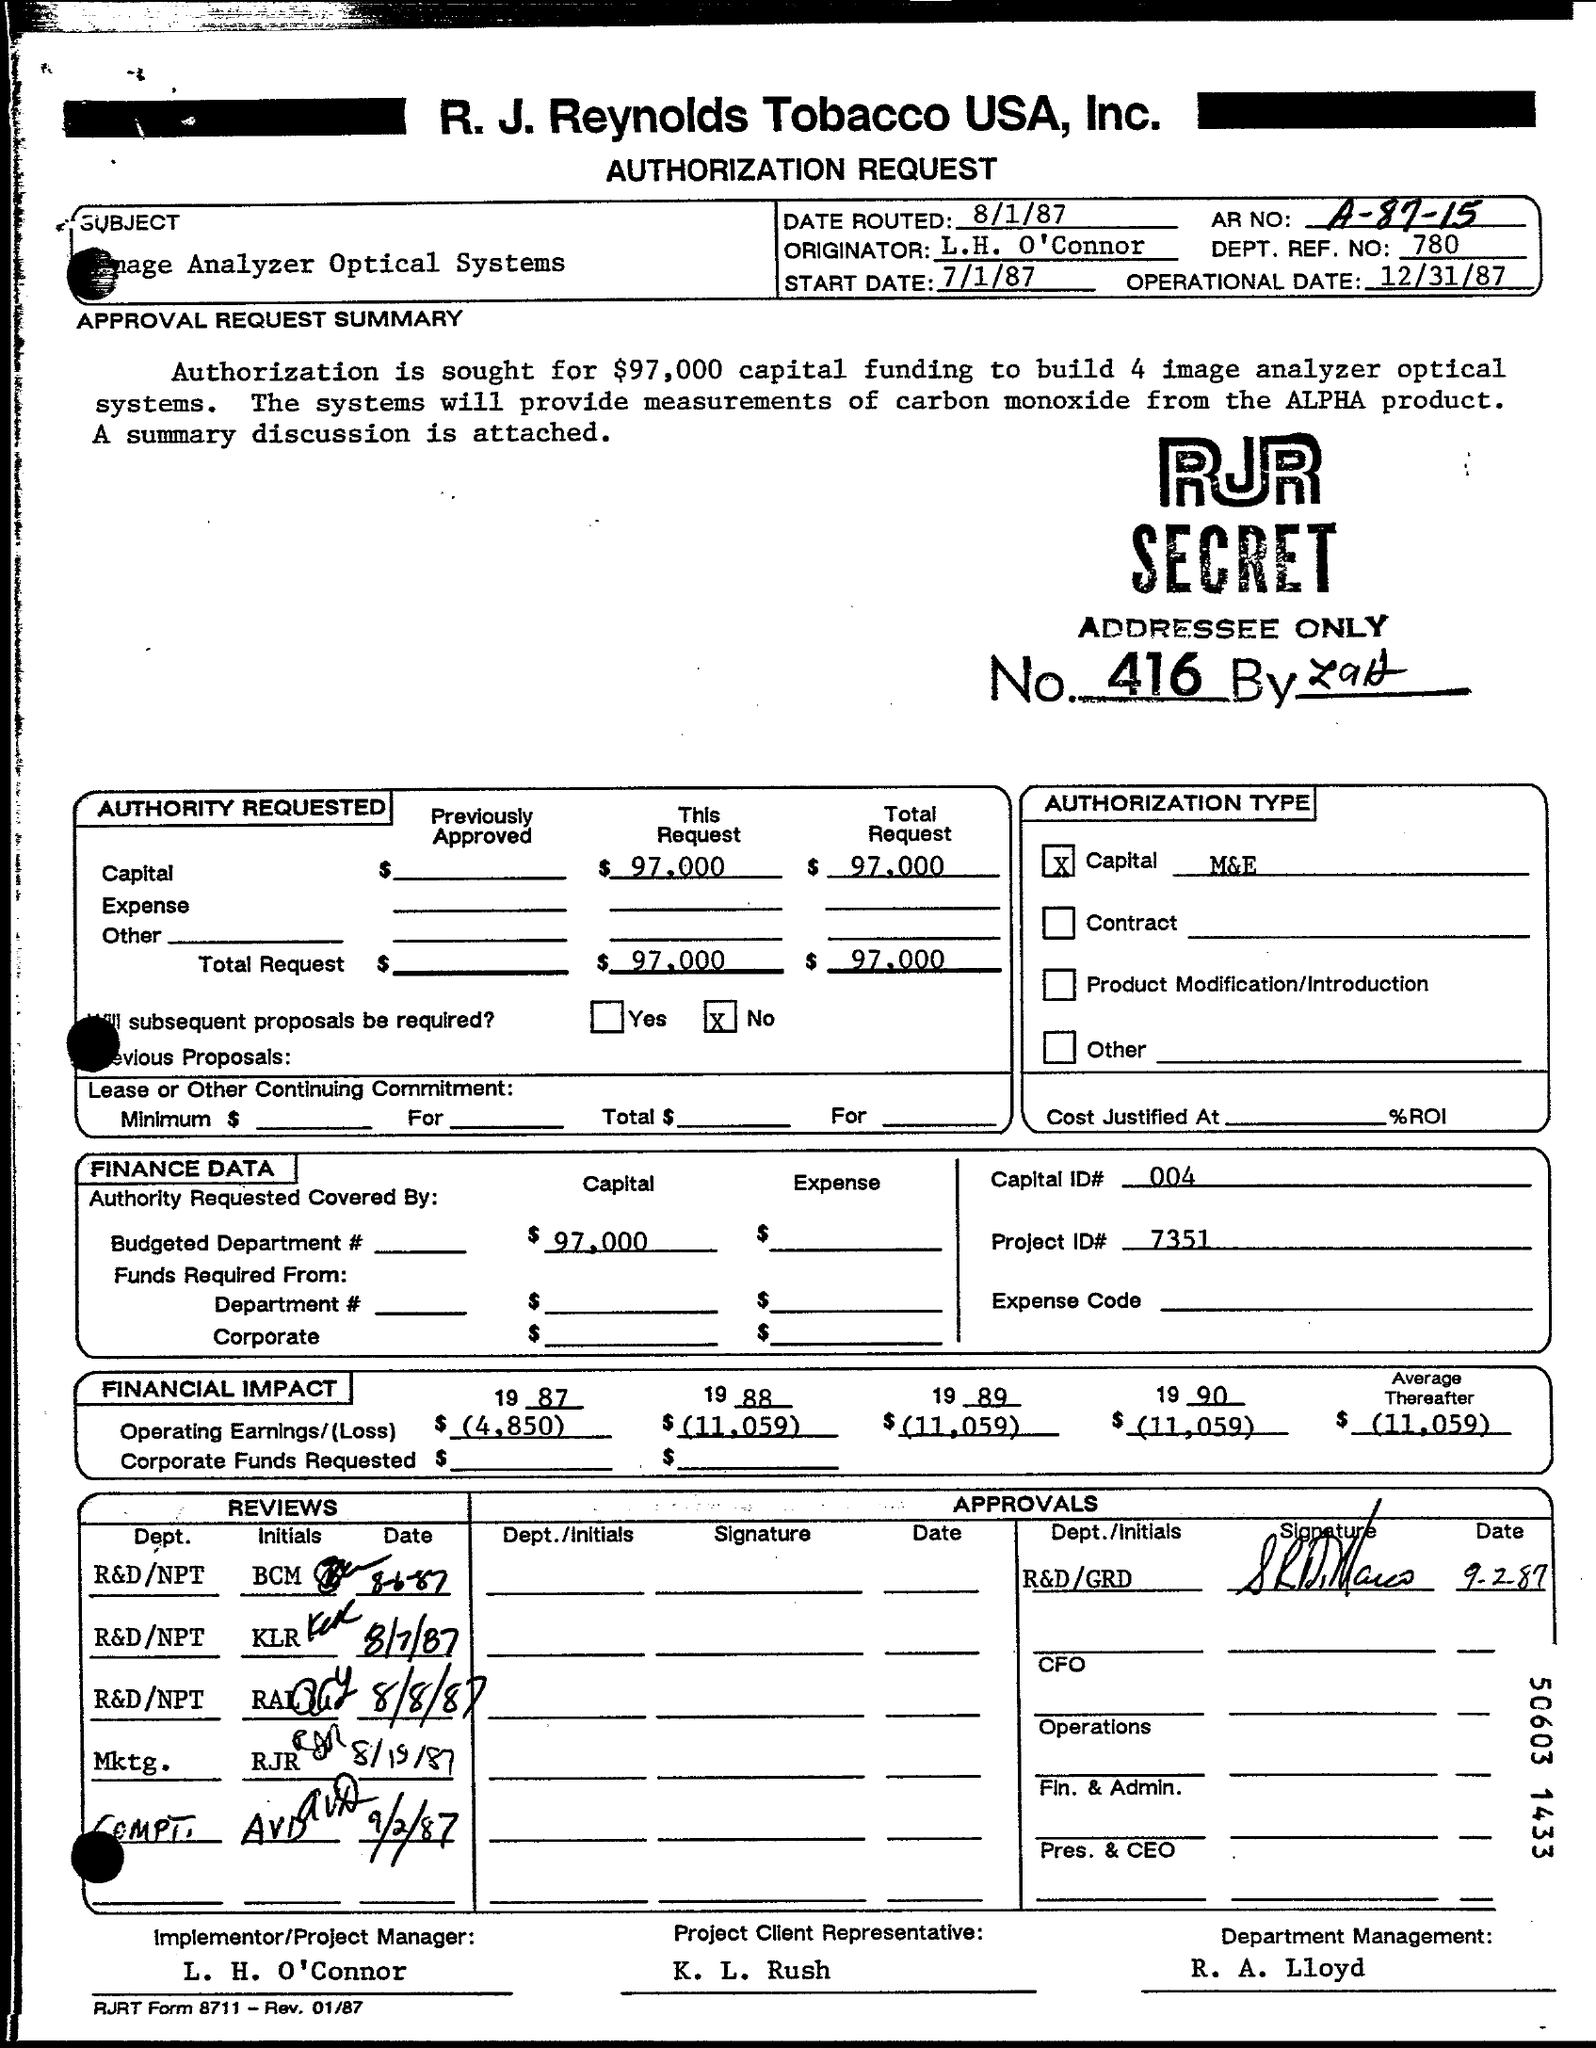What is operational date?
Offer a terse response. 12/31/87. What is start date?
Your answer should be compact. 7/1/87. What is AR No:?
Make the answer very short. A-87-15. What is date routed?
Offer a very short reply. 8/1/87. 